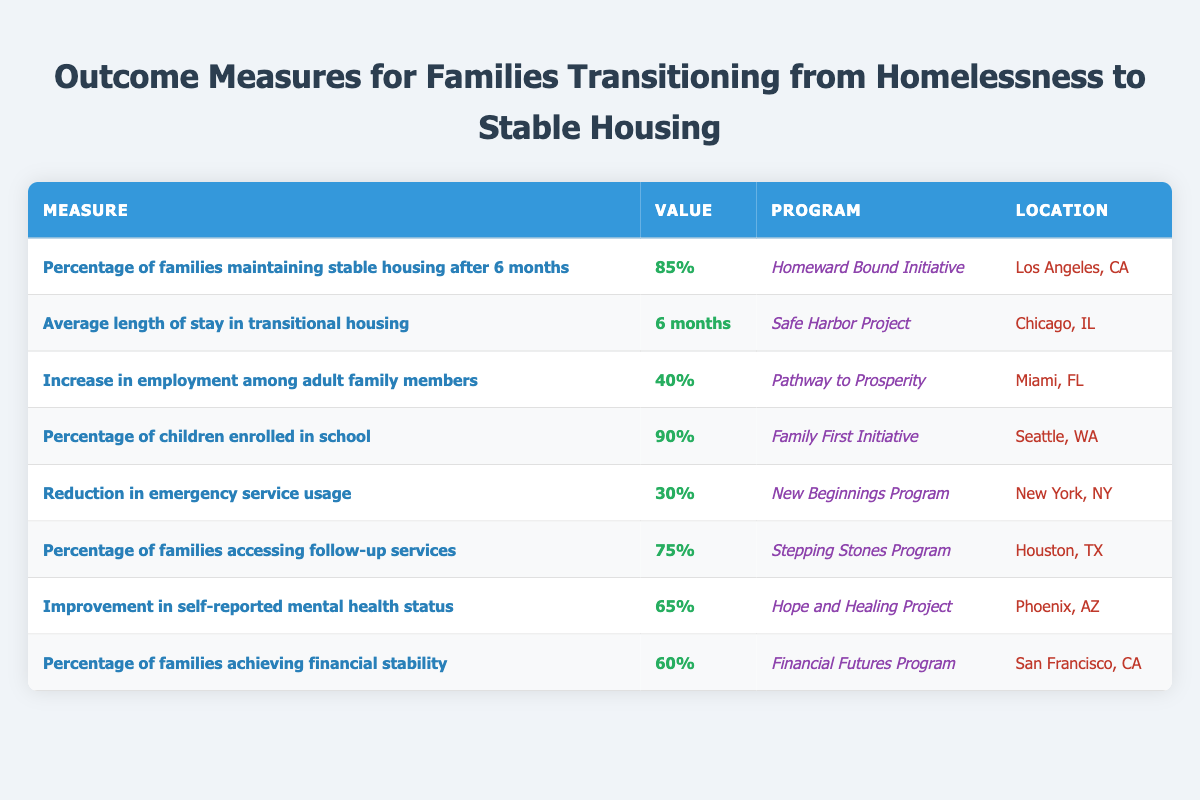What is the percentage of families maintaining stable housing after 6 months? The table shows the measure "Percentage of families maintaining stable housing after 6 months" with a value of 85%.
Answer: 85% Which program achieved a 90% enrollment rate of children in school? According to the table, the program "Family First Initiative" has a value of 90% for the measure of children enrolled in school.
Answer: Family First Initiative How many programs reported an increase in employment among adult family members? The table lists only one program, "Pathway to Prosperity," which reports a 40% increase in employment among adult family members.
Answer: 1 What is the average length of stay in transitional housing across the programs listed? The table features one program named "Safe Harbor Project" with an average length of stay value of 6 months, and since no other durations are provided, we take this as the average.
Answer: 6 months Is the percentage of families accessing follow-up services higher than those achieving financial stability? The table shows that 75% of families access follow-up services, while 60% achieve financial stability. Since 75% is greater than 60%, the answer is yes.
Answer: Yes What is the total percentage of families that either maintained stable housing or accessed follow-up services? The percentage of families maintaining stable housing is 85%, and those accessing follow-up services is 75%. Adding both gives 85% + 75% = 160%.
Answer: 160% Which program reported a 30% reduction in emergency service usage, and in what location? "New Beginnings Program" reported a 30% reduction in emergency service usage, and it is located in New York, NY.
Answer: New Beginnings Program, New York, NY How many measures report a percentage over 70%? The table shows measures for percentage of families maintaining stable housing (85%), children enrolled in school (90%), families accessing follow-up services (75%), and improvement in self-reported mental health status (65%). Thus, the counts for over 70% are three: 85%, 90%, and 75%.
Answer: 3 What percentage of families reported an improvement in self-reported mental health status? The measure "Improvement in self-reported mental health status" has a value of 65% in the table.
Answer: 65% Which program has the highest reported outcome measure value and what is that value? The highest percentage in the table is 90% for children enrolled in school, reported by the "Family First Initiative".
Answer: Family First Initiative, 90% 